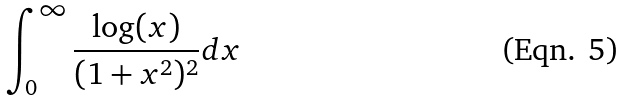Convert formula to latex. <formula><loc_0><loc_0><loc_500><loc_500>\int _ { 0 } ^ { \infty } \frac { \log ( x ) } { ( 1 + x ^ { 2 } ) ^ { 2 } } d x</formula> 